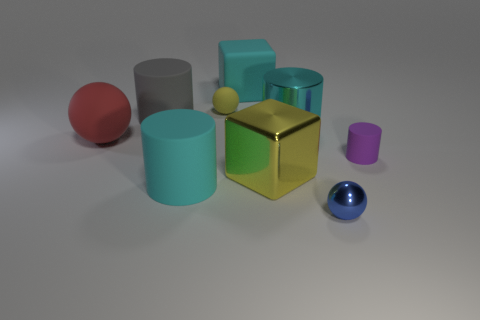Subtract all tiny purple matte cylinders. How many cylinders are left? 3 Subtract all cyan blocks. How many blocks are left? 1 Add 1 matte spheres. How many objects exist? 10 Subtract 3 cylinders. How many cylinders are left? 1 Subtract all balls. How many objects are left? 6 Subtract all gray spheres. How many gray cylinders are left? 1 Subtract all blue metallic balls. Subtract all purple matte cylinders. How many objects are left? 7 Add 2 big gray cylinders. How many big gray cylinders are left? 3 Add 1 tiny green metal objects. How many tiny green metal objects exist? 1 Subtract 0 blue cylinders. How many objects are left? 9 